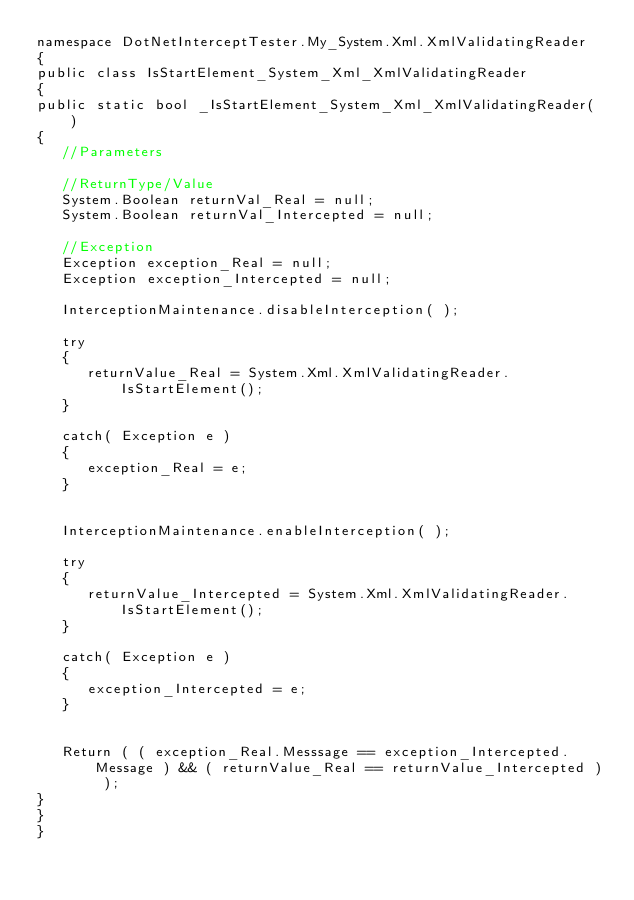<code> <loc_0><loc_0><loc_500><loc_500><_C#_>namespace DotNetInterceptTester.My_System.Xml.XmlValidatingReader
{
public class IsStartElement_System_Xml_XmlValidatingReader
{
public static bool _IsStartElement_System_Xml_XmlValidatingReader( )
{
   //Parameters

   //ReturnType/Value
   System.Boolean returnVal_Real = null;
   System.Boolean returnVal_Intercepted = null;

   //Exception
   Exception exception_Real = null;
   Exception exception_Intercepted = null;

   InterceptionMaintenance.disableInterception( );

   try
   {
      returnValue_Real = System.Xml.XmlValidatingReader.IsStartElement();
   }

   catch( Exception e )
   {
      exception_Real = e;
   }


   InterceptionMaintenance.enableInterception( );

   try
   {
      returnValue_Intercepted = System.Xml.XmlValidatingReader.IsStartElement();
   }

   catch( Exception e )
   {
      exception_Intercepted = e;
   }


   Return ( ( exception_Real.Messsage == exception_Intercepted.Message ) && ( returnValue_Real == returnValue_Intercepted ) );
}
}
}
</code> 